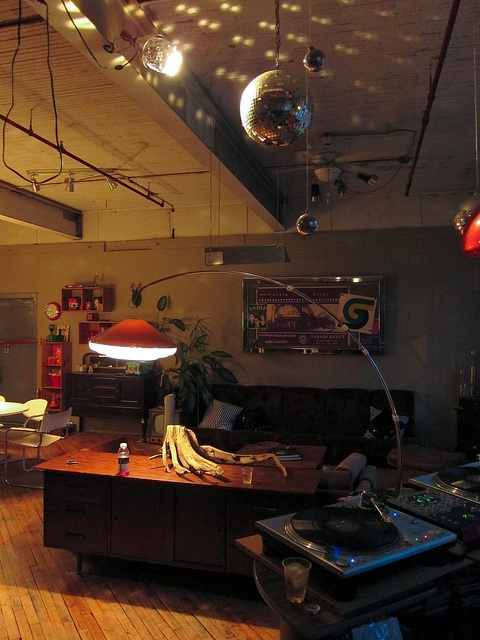Describe the objects in this image and their specific colors. I can see couch in maroon, black, and gray tones, potted plant in maroon, black, and gray tones, chair in maroon, black, and brown tones, cup in maroon, black, and gray tones, and chair in maroon, khaki, beige, and gray tones in this image. 